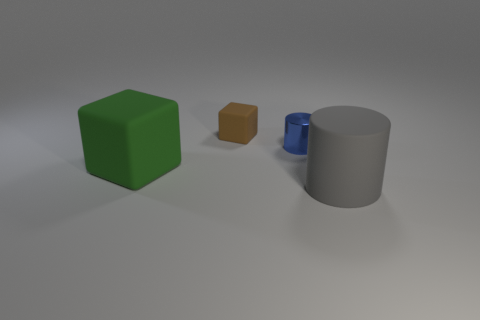What size is the brown object?
Ensure brevity in your answer.  Small. What number of other things are the same color as the matte cylinder?
Provide a succinct answer. 0. What color is the thing that is both to the left of the blue cylinder and in front of the small blue cylinder?
Give a very brief answer. Green. How many tiny blue things are there?
Offer a terse response. 1. Is the brown object made of the same material as the green block?
Keep it short and to the point. Yes. What is the shape of the big matte thing on the left side of the rubber thing that is in front of the big object behind the big gray rubber thing?
Your answer should be compact. Cube. Is the material of the big thing that is behind the large gray matte object the same as the tiny object to the left of the blue cylinder?
Provide a succinct answer. Yes. What is the big gray cylinder made of?
Provide a succinct answer. Rubber. How many large objects are the same shape as the small matte thing?
Your answer should be compact. 1. Are there any other things that have the same shape as the large gray rubber object?
Your answer should be very brief. Yes. 